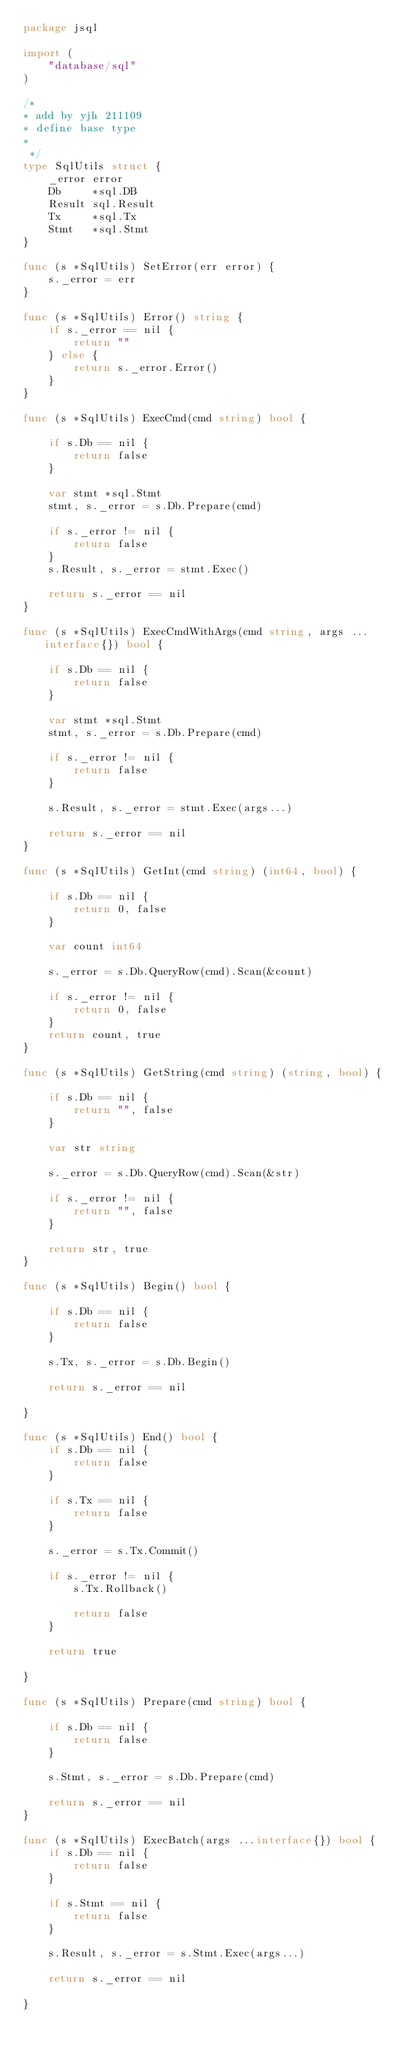<code> <loc_0><loc_0><loc_500><loc_500><_Go_>package jsql

import (
	"database/sql"
)

/*
* add by yjh 211109
* define base type
*
 */
type SqlUtils struct {
	_error error
	Db     *sql.DB
	Result sql.Result
	Tx     *sql.Tx
	Stmt   *sql.Stmt
}

func (s *SqlUtils) SetError(err error) {
	s._error = err
}

func (s *SqlUtils) Error() string {
	if s._error == nil {
		return ""
	} else {
		return s._error.Error()
	}
}

func (s *SqlUtils) ExecCmd(cmd string) bool {

	if s.Db == nil {
		return false
	}

	var stmt *sql.Stmt
	stmt, s._error = s.Db.Prepare(cmd)

	if s._error != nil {
		return false
	}
	s.Result, s._error = stmt.Exec()

	return s._error == nil
}

func (s *SqlUtils) ExecCmdWithArgs(cmd string, args ...interface{}) bool {

	if s.Db == nil {
		return false
	}

	var stmt *sql.Stmt
	stmt, s._error = s.Db.Prepare(cmd)

	if s._error != nil {
		return false
	}

	s.Result, s._error = stmt.Exec(args...)

	return s._error == nil
}

func (s *SqlUtils) GetInt(cmd string) (int64, bool) {

	if s.Db == nil {
		return 0, false
	}

	var count int64

	s._error = s.Db.QueryRow(cmd).Scan(&count)

	if s._error != nil {
		return 0, false
	}
	return count, true
}

func (s *SqlUtils) GetString(cmd string) (string, bool) {

	if s.Db == nil {
		return "", false
	}

	var str string

	s._error = s.Db.QueryRow(cmd).Scan(&str)

	if s._error != nil {
		return "", false
	}

	return str, true
}

func (s *SqlUtils) Begin() bool {

	if s.Db == nil {
		return false
	}

	s.Tx, s._error = s.Db.Begin()

	return s._error == nil

}

func (s *SqlUtils) End() bool {
	if s.Db == nil {
		return false
	}

	if s.Tx == nil {
		return false
	}

	s._error = s.Tx.Commit()

	if s._error != nil {
		s.Tx.Rollback()

		return false
	}

	return true

}

func (s *SqlUtils) Prepare(cmd string) bool {

	if s.Db == nil {
		return false
	}

	s.Stmt, s._error = s.Db.Prepare(cmd)

	return s._error == nil
}

func (s *SqlUtils) ExecBatch(args ...interface{}) bool {
	if s.Db == nil {
		return false
	}

	if s.Stmt == nil {
		return false
	}

	s.Result, s._error = s.Stmt.Exec(args...)

	return s._error == nil

}
</code> 